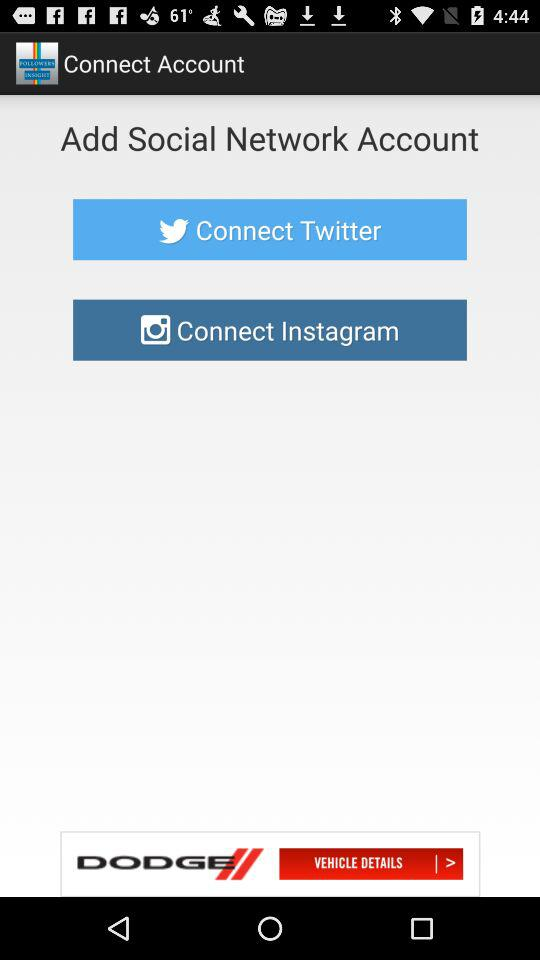What is the name of the user's account?
When the provided information is insufficient, respond with <no answer>. <no answer> 